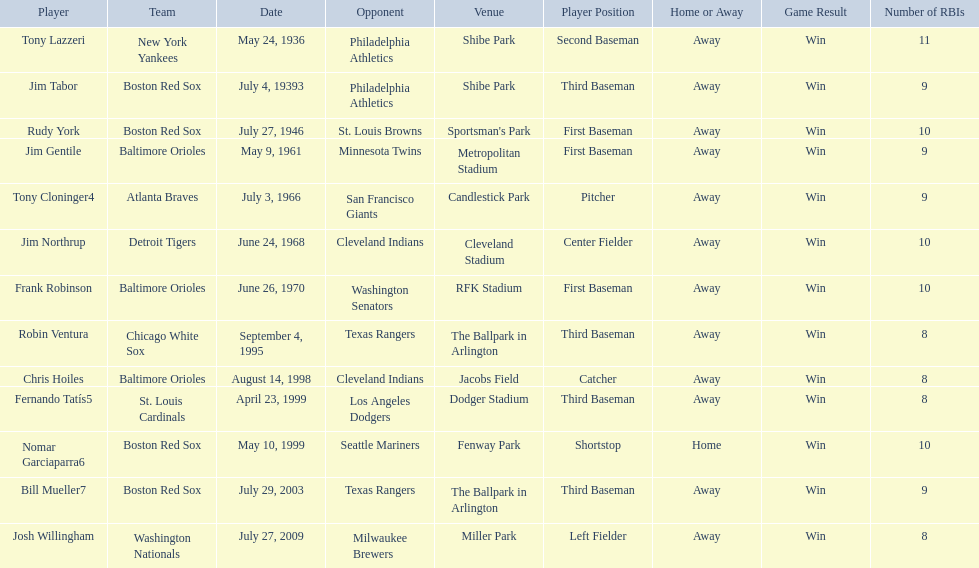Who were all the teams? New York Yankees, Boston Red Sox, Boston Red Sox, Baltimore Orioles, Atlanta Braves, Detroit Tigers, Baltimore Orioles, Chicago White Sox, Baltimore Orioles, St. Louis Cardinals, Boston Red Sox, Boston Red Sox, Washington Nationals. What about opponents? Philadelphia Athletics, Philadelphia Athletics, St. Louis Browns, Minnesota Twins, San Francisco Giants, Cleveland Indians, Washington Senators, Texas Rangers, Cleveland Indians, Los Angeles Dodgers, Seattle Mariners, Texas Rangers, Milwaukee Brewers. And when did they play? May 24, 1936, July 4, 19393, July 27, 1946, May 9, 1961, July 3, 1966, June 24, 1968, June 26, 1970, September 4, 1995, August 14, 1998, April 23, 1999, May 10, 1999, July 29, 2003, July 27, 2009. Which team played the red sox on july 27, 1946	? St. Louis Browns. 